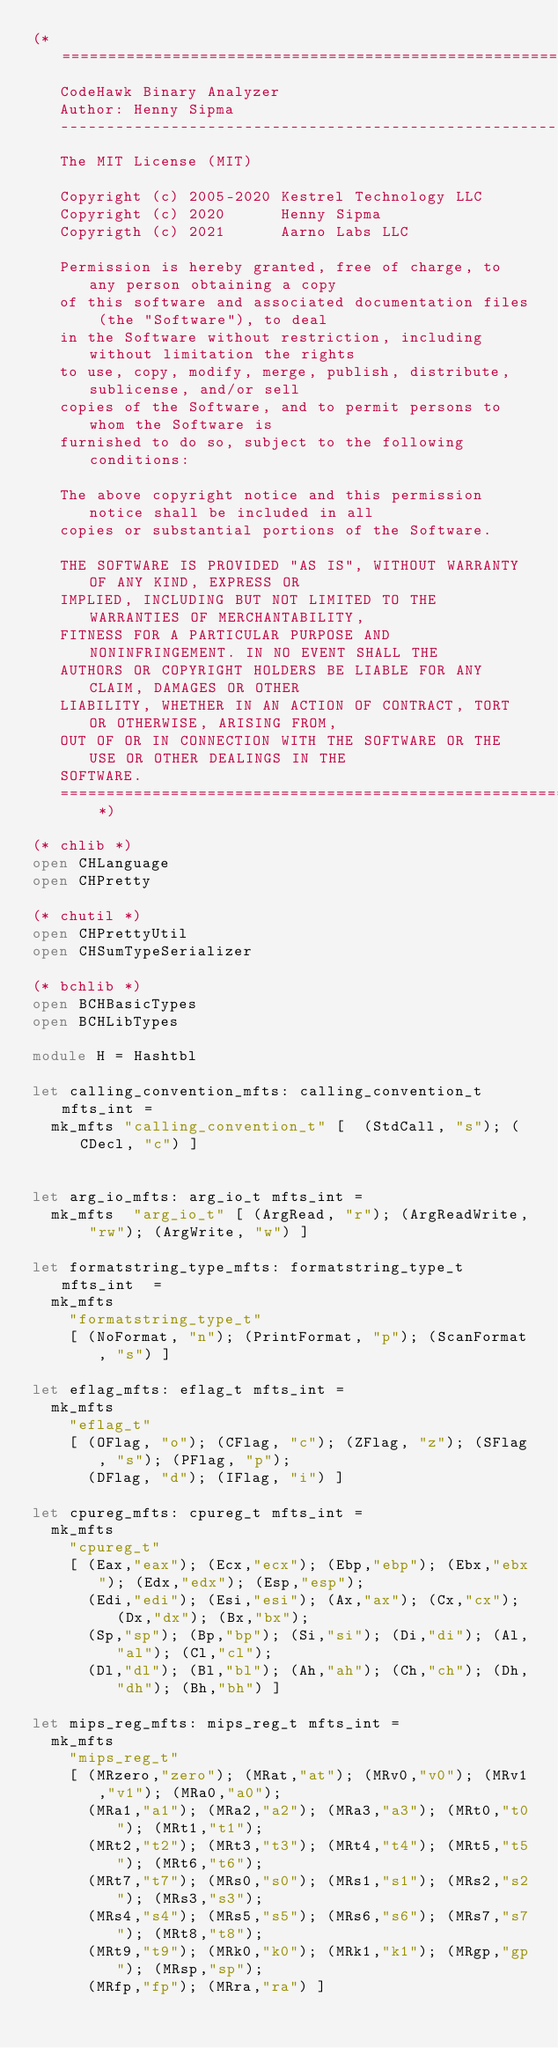Convert code to text. <code><loc_0><loc_0><loc_500><loc_500><_OCaml_>(* =============================================================================
   CodeHawk Binary Analyzer 
   Author: Henny Sipma
   ------------------------------------------------------------------------------
   The MIT License (MIT)
 
   Copyright (c) 2005-2020 Kestrel Technology LLC
   Copyright (c) 2020      Henny Sipma
   Copyrigth (c) 2021      Aarno Labs LLC

   Permission is hereby granted, free of charge, to any person obtaining a copy
   of this software and associated documentation files (the "Software"), to deal
   in the Software without restriction, including without limitation the rights
   to use, copy, modify, merge, publish, distribute, sublicense, and/or sell
   copies of the Software, and to permit persons to whom the Software is
   furnished to do so, subject to the following conditions:
 
   The above copyright notice and this permission notice shall be included in all
   copies or substantial portions of the Software.
  
   THE SOFTWARE IS PROVIDED "AS IS", WITHOUT WARRANTY OF ANY KIND, EXPRESS OR
   IMPLIED, INCLUDING BUT NOT LIMITED TO THE WARRANTIES OF MERCHANTABILITY,
   FITNESS FOR A PARTICULAR PURPOSE AND NONINFRINGEMENT. IN NO EVENT SHALL THE
   AUTHORS OR COPYRIGHT HOLDERS BE LIABLE FOR ANY CLAIM, DAMAGES OR OTHER
   LIABILITY, WHETHER IN AN ACTION OF CONTRACT, TORT OR OTHERWISE, ARISING FROM,
   OUT OF OR IN CONNECTION WITH THE SOFTWARE OR THE USE OR OTHER DEALINGS IN THE
   SOFTWARE.
   ============================================================================= *)

(* chlib *)
open CHLanguage
open CHPretty

(* chutil *)
open CHPrettyUtil
open CHSumTypeSerializer

(* bchlib *)
open BCHBasicTypes
open BCHLibTypes

module H = Hashtbl
         
let calling_convention_mfts: calling_convention_t mfts_int =
  mk_mfts "calling_convention_t" [  (StdCall, "s"); (CDecl, "c") ]

  
let arg_io_mfts: arg_io_t mfts_int =
  mk_mfts  "arg_io_t" [ (ArgRead, "r"); (ArgReadWrite, "rw"); (ArgWrite, "w") ]

let formatstring_type_mfts: formatstring_type_t mfts_int  =
  mk_mfts
    "formatstring_type_t"
    [ (NoFormat, "n"); (PrintFormat, "p"); (ScanFormat, "s") ]

let eflag_mfts: eflag_t mfts_int =
  mk_mfts
    "eflag_t"
    [ (OFlag, "o"); (CFlag, "c"); (ZFlag, "z"); (SFlag, "s"); (PFlag, "p");
      (DFlag, "d"); (IFlag, "i") ]

let cpureg_mfts: cpureg_t mfts_int =
  mk_mfts
    "cpureg_t"
    [ (Eax,"eax"); (Ecx,"ecx"); (Ebp,"ebp"); (Ebx,"ebx"); (Edx,"edx"); (Esp,"esp");
      (Edi,"edi"); (Esi,"esi"); (Ax,"ax"); (Cx,"cx"); (Dx,"dx"); (Bx,"bx");
      (Sp,"sp"); (Bp,"bp"); (Si,"si"); (Di,"di"); (Al,"al"); (Cl,"cl");
      (Dl,"dl"); (Bl,"bl"); (Ah,"ah"); (Ch,"ch"); (Dh,"dh"); (Bh,"bh") ]

let mips_reg_mfts: mips_reg_t mfts_int =
  mk_mfts
    "mips_reg_t"
    [ (MRzero,"zero"); (MRat,"at"); (MRv0,"v0"); (MRv1,"v1"); (MRa0,"a0");
      (MRa1,"a1"); (MRa2,"a2"); (MRa3,"a3"); (MRt0,"t0"); (MRt1,"t1");
      (MRt2,"t2"); (MRt3,"t3"); (MRt4,"t4"); (MRt5,"t5"); (MRt6,"t6");
      (MRt7,"t7"); (MRs0,"s0"); (MRs1,"s1"); (MRs2,"s2"); (MRs3,"s3");
      (MRs4,"s4"); (MRs5,"s5"); (MRs6,"s6"); (MRs7,"s7"); (MRt8,"t8");
      (MRt9,"t9"); (MRk0,"k0"); (MRk1,"k1"); (MRgp,"gp"); (MRsp,"sp");
      (MRfp,"fp"); (MRra,"ra") ]
</code> 